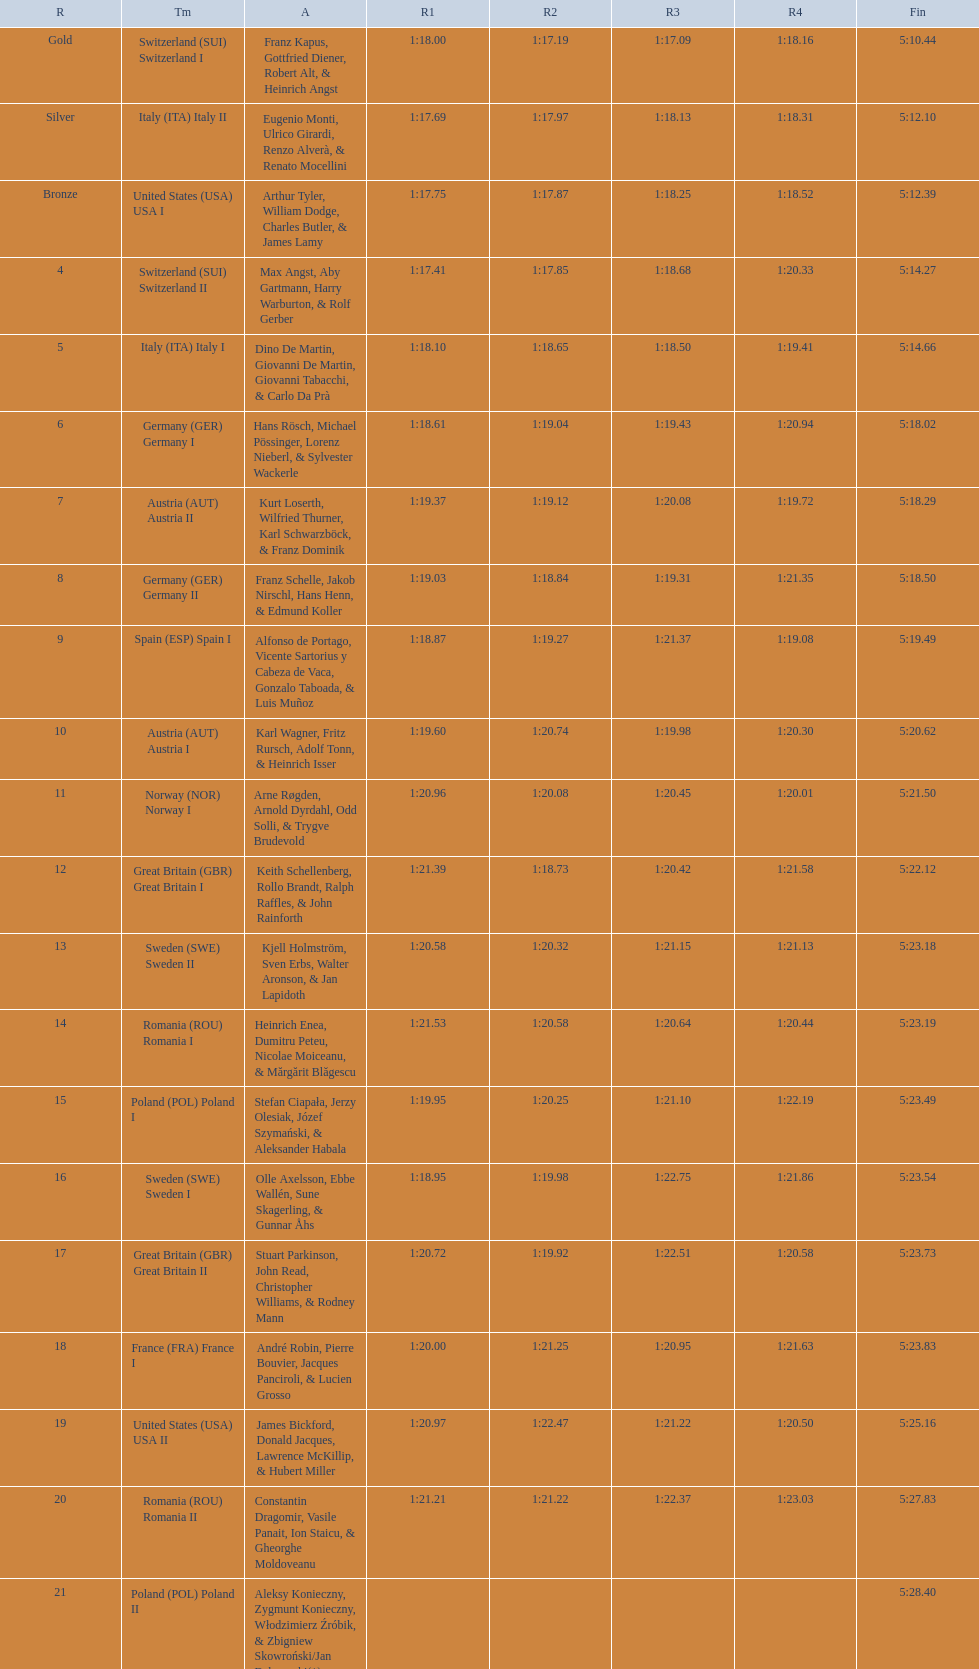Write the full table. {'header': ['R', 'Tm', 'A', 'R1', 'R2', 'R3', 'R4', 'Fin'], 'rows': [['Gold', 'Switzerland\xa0(SUI) Switzerland I', 'Franz Kapus, Gottfried Diener, Robert Alt, & Heinrich Angst', '1:18.00', '1:17.19', '1:17.09', '1:18.16', '5:10.44'], ['Silver', 'Italy\xa0(ITA) Italy II', 'Eugenio Monti, Ulrico Girardi, Renzo Alverà, & Renato Mocellini', '1:17.69', '1:17.97', '1:18.13', '1:18.31', '5:12.10'], ['Bronze', 'United States\xa0(USA) USA I', 'Arthur Tyler, William Dodge, Charles Butler, & James Lamy', '1:17.75', '1:17.87', '1:18.25', '1:18.52', '5:12.39'], ['4', 'Switzerland\xa0(SUI) Switzerland II', 'Max Angst, Aby Gartmann, Harry Warburton, & Rolf Gerber', '1:17.41', '1:17.85', '1:18.68', '1:20.33', '5:14.27'], ['5', 'Italy\xa0(ITA) Italy I', 'Dino De Martin, Giovanni De Martin, Giovanni Tabacchi, & Carlo Da Prà', '1:18.10', '1:18.65', '1:18.50', '1:19.41', '5:14.66'], ['6', 'Germany\xa0(GER) Germany I', 'Hans Rösch, Michael Pössinger, Lorenz Nieberl, & Sylvester Wackerle', '1:18.61', '1:19.04', '1:19.43', '1:20.94', '5:18.02'], ['7', 'Austria\xa0(AUT) Austria II', 'Kurt Loserth, Wilfried Thurner, Karl Schwarzböck, & Franz Dominik', '1:19.37', '1:19.12', '1:20.08', '1:19.72', '5:18.29'], ['8', 'Germany\xa0(GER) Germany II', 'Franz Schelle, Jakob Nirschl, Hans Henn, & Edmund Koller', '1:19.03', '1:18.84', '1:19.31', '1:21.35', '5:18.50'], ['9', 'Spain\xa0(ESP) Spain I', 'Alfonso de Portago, Vicente Sartorius y Cabeza de Vaca, Gonzalo Taboada, & Luis Muñoz', '1:18.87', '1:19.27', '1:21.37', '1:19.08', '5:19.49'], ['10', 'Austria\xa0(AUT) Austria I', 'Karl Wagner, Fritz Rursch, Adolf Tonn, & Heinrich Isser', '1:19.60', '1:20.74', '1:19.98', '1:20.30', '5:20.62'], ['11', 'Norway\xa0(NOR) Norway I', 'Arne Røgden, Arnold Dyrdahl, Odd Solli, & Trygve Brudevold', '1:20.96', '1:20.08', '1:20.45', '1:20.01', '5:21.50'], ['12', 'Great Britain\xa0(GBR) Great Britain I', 'Keith Schellenberg, Rollo Brandt, Ralph Raffles, & John Rainforth', '1:21.39', '1:18.73', '1:20.42', '1:21.58', '5:22.12'], ['13', 'Sweden\xa0(SWE) Sweden II', 'Kjell Holmström, Sven Erbs, Walter Aronson, & Jan Lapidoth', '1:20.58', '1:20.32', '1:21.15', '1:21.13', '5:23.18'], ['14', 'Romania\xa0(ROU) Romania I', 'Heinrich Enea, Dumitru Peteu, Nicolae Moiceanu, & Mărgărit Blăgescu', '1:21.53', '1:20.58', '1:20.64', '1:20.44', '5:23.19'], ['15', 'Poland\xa0(POL) Poland I', 'Stefan Ciapała, Jerzy Olesiak, Józef Szymański, & Aleksander Habala', '1:19.95', '1:20.25', '1:21.10', '1:22.19', '5:23.49'], ['16', 'Sweden\xa0(SWE) Sweden I', 'Olle Axelsson, Ebbe Wallén, Sune Skagerling, & Gunnar Åhs', '1:18.95', '1:19.98', '1:22.75', '1:21.86', '5:23.54'], ['17', 'Great Britain\xa0(GBR) Great Britain II', 'Stuart Parkinson, John Read, Christopher Williams, & Rodney Mann', '1:20.72', '1:19.92', '1:22.51', '1:20.58', '5:23.73'], ['18', 'France\xa0(FRA) France I', 'André Robin, Pierre Bouvier, Jacques Panciroli, & Lucien Grosso', '1:20.00', '1:21.25', '1:20.95', '1:21.63', '5:23.83'], ['19', 'United States\xa0(USA) USA II', 'James Bickford, Donald Jacques, Lawrence McKillip, & Hubert Miller', '1:20.97', '1:22.47', '1:21.22', '1:20.50', '5:25.16'], ['20', 'Romania\xa0(ROU) Romania II', 'Constantin Dragomir, Vasile Panait, Ion Staicu, & Gheorghe Moldoveanu', '1:21.21', '1:21.22', '1:22.37', '1:23.03', '5:27.83'], ['21', 'Poland\xa0(POL) Poland II', 'Aleksy Konieczny, Zygmunt Konieczny, Włodzimierz Źróbik, & Zbigniew Skowroński/Jan Dąbrowski(*)', '', '', '', '', '5:28.40']]} What team comes after italy (ita) italy i? Germany I. 